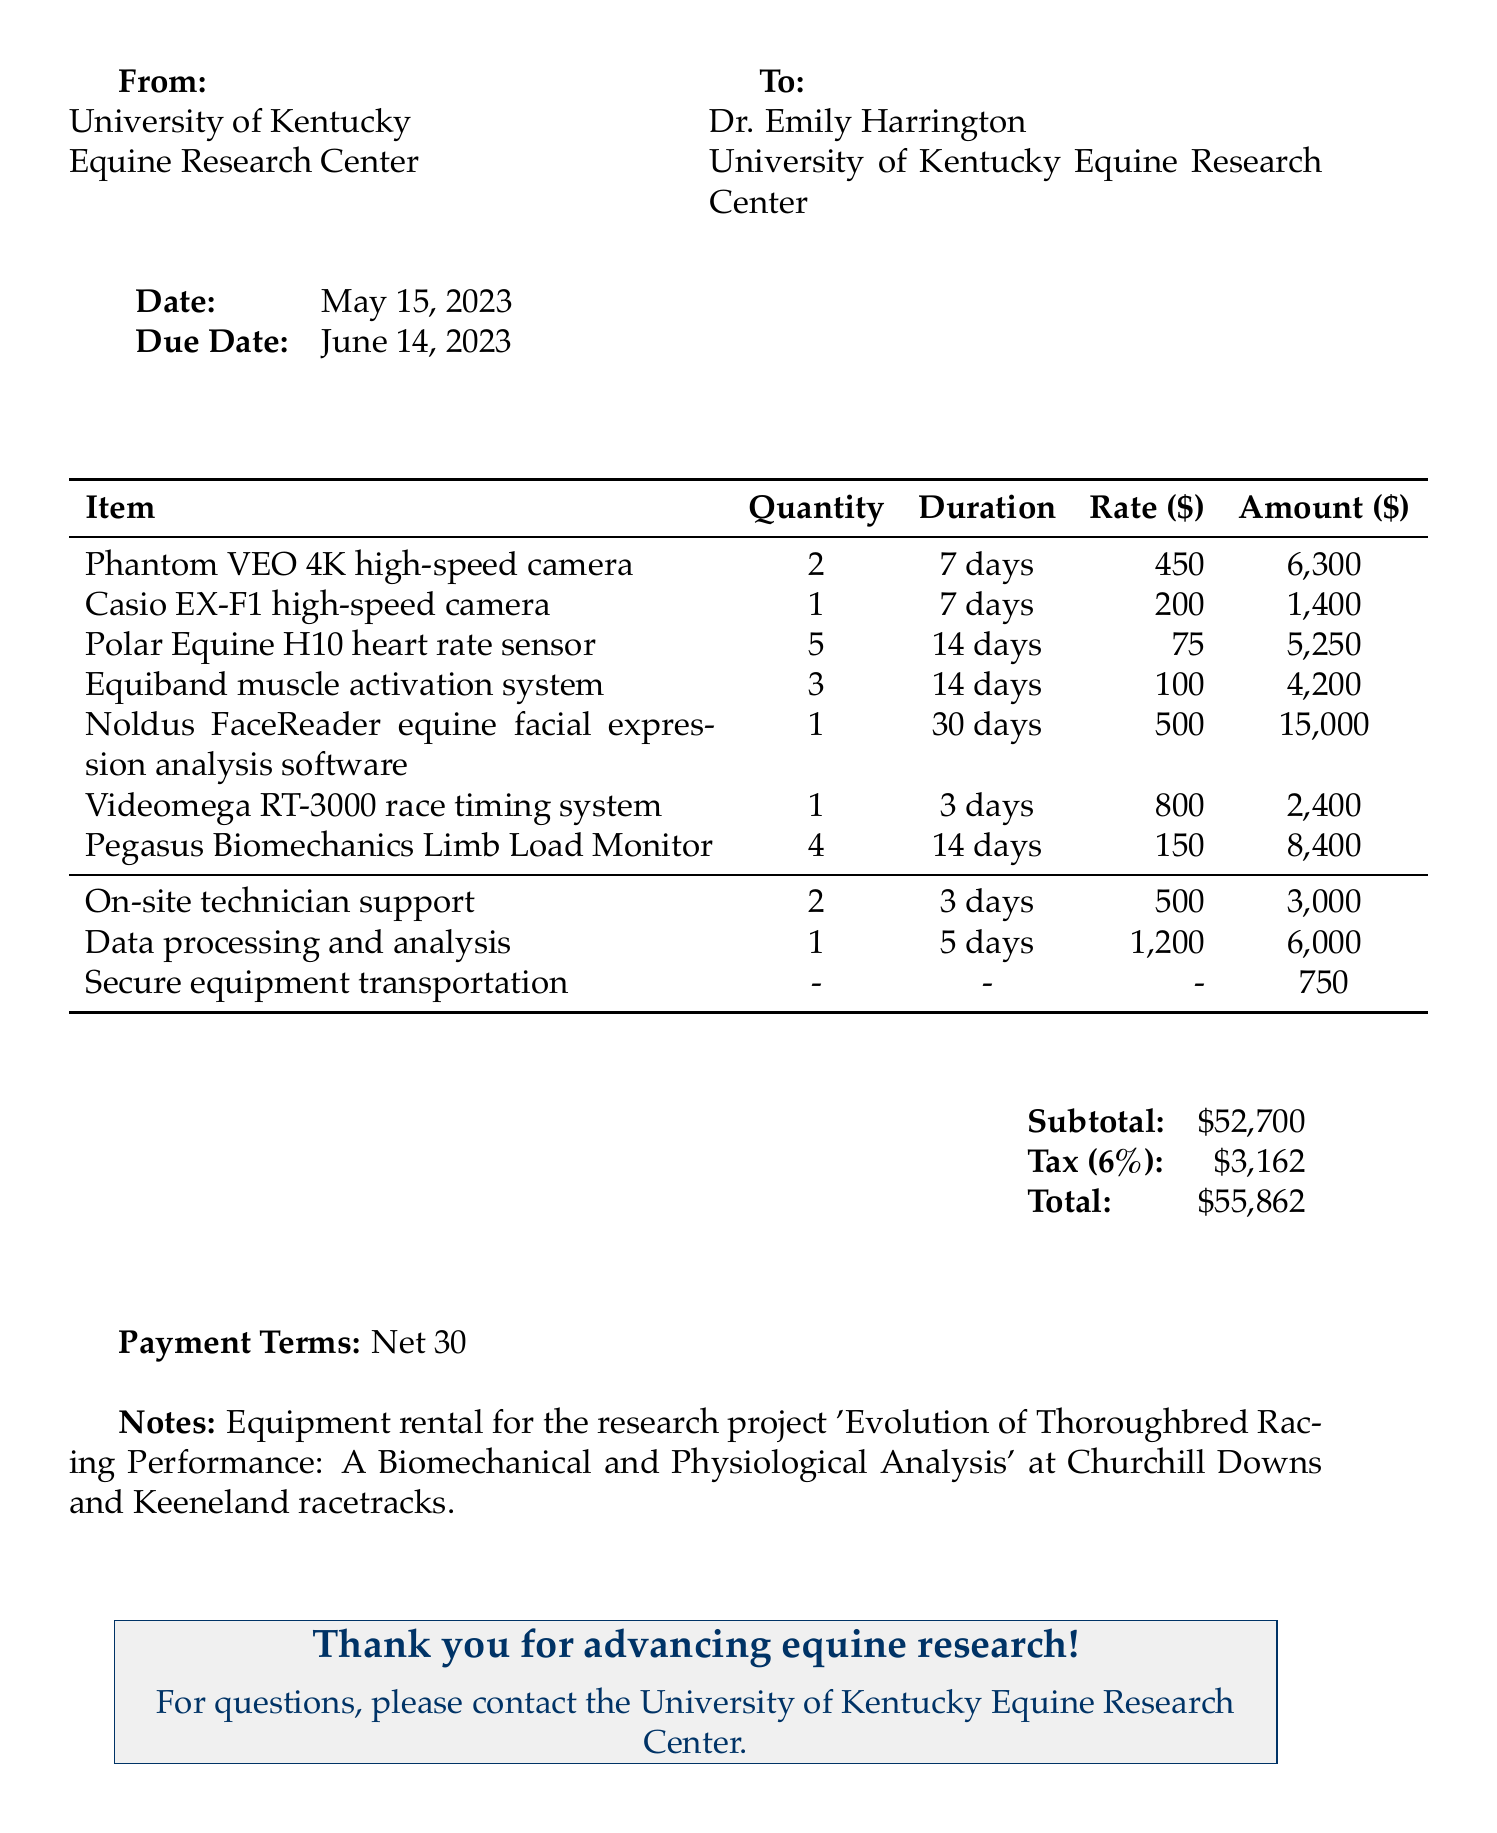what is the invoice number? The invoice number is stated clearly in the document's header as EQ-2023-0542.
Answer: EQ-2023-0542 who is the researcher? The researcher's name is provided in the document as Dr. Emily Harrington.
Answer: Dr. Emily Harrington what is the due date for the invoice? The due date is mentioned in the document, which is set for June 14, 2023.
Answer: June 14, 2023 how many Polar Equine H10 heart rate sensors were rented? The quantity of Polar Equine H10 heart rate sensors is listed as 5.
Answer: 5 what is the total amount due? The total amount due is the final calculated figure at the bottom of the invoice, which includes tax.
Answer: $55,862 what is the subtotal before tax? The subtotal is the sum of all equipment rentals and additional services before tax is added.
Answer: $52,700 which institution is associated with this invoice? The institution is stated in the "From" section of the document as University of Kentucky Equine Research Center.
Answer: University of Kentucky Equine Research Center what additional service was provided for data analysis? The additional service listed for analysis is titled "Data processing and analysis."
Answer: Data processing and analysis how long was the Noldus FaceReader software rented for? The rental duration for the Noldus FaceReader software is clearly stated as 30 days.
Answer: 30 days 